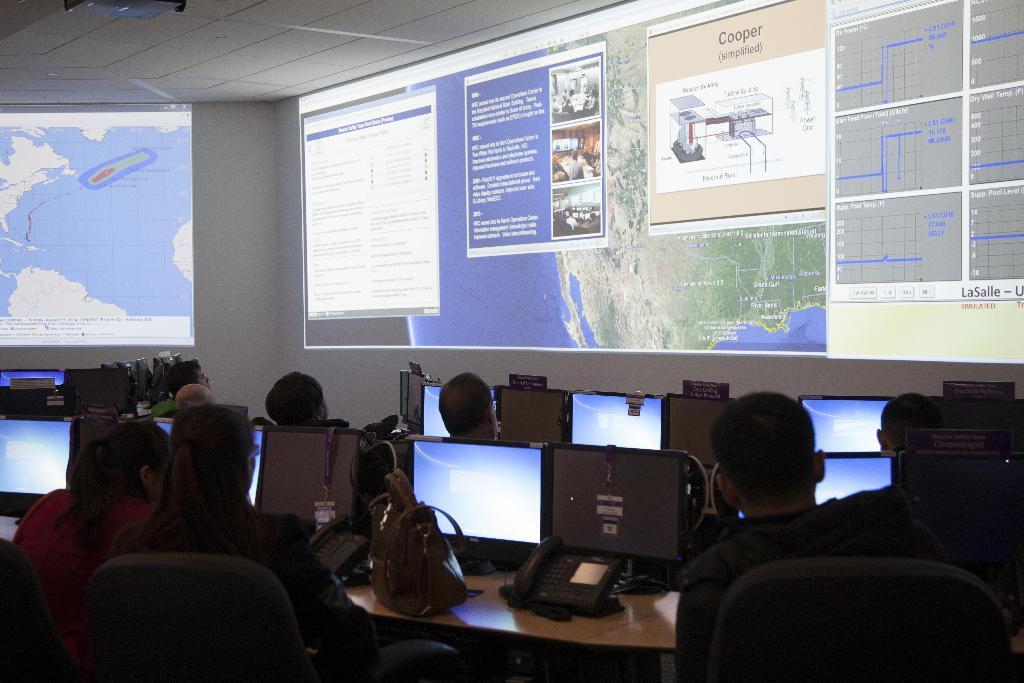Could you give a brief overview of what you see in this image? In this picture we can see some persons sitting on the chairs. This is the table. On the table there are some monitors. And this is the screen and there is a wall. 